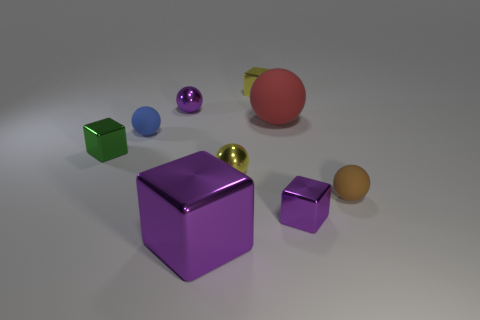Subtract all purple blocks. How many were subtracted if there are1purple blocks left? 1 Subtract all green cubes. How many cubes are left? 3 Subtract all red rubber spheres. How many spheres are left? 4 Subtract 2 spheres. How many spheres are left? 3 Subtract all brown spheres. Subtract all blue blocks. How many spheres are left? 4 Subtract all blue cubes. How many red balls are left? 1 Subtract all brown spheres. Subtract all big metal cylinders. How many objects are left? 8 Add 6 big shiny cubes. How many big shiny cubes are left? 7 Add 2 gray shiny balls. How many gray shiny balls exist? 2 Subtract 0 gray balls. How many objects are left? 9 